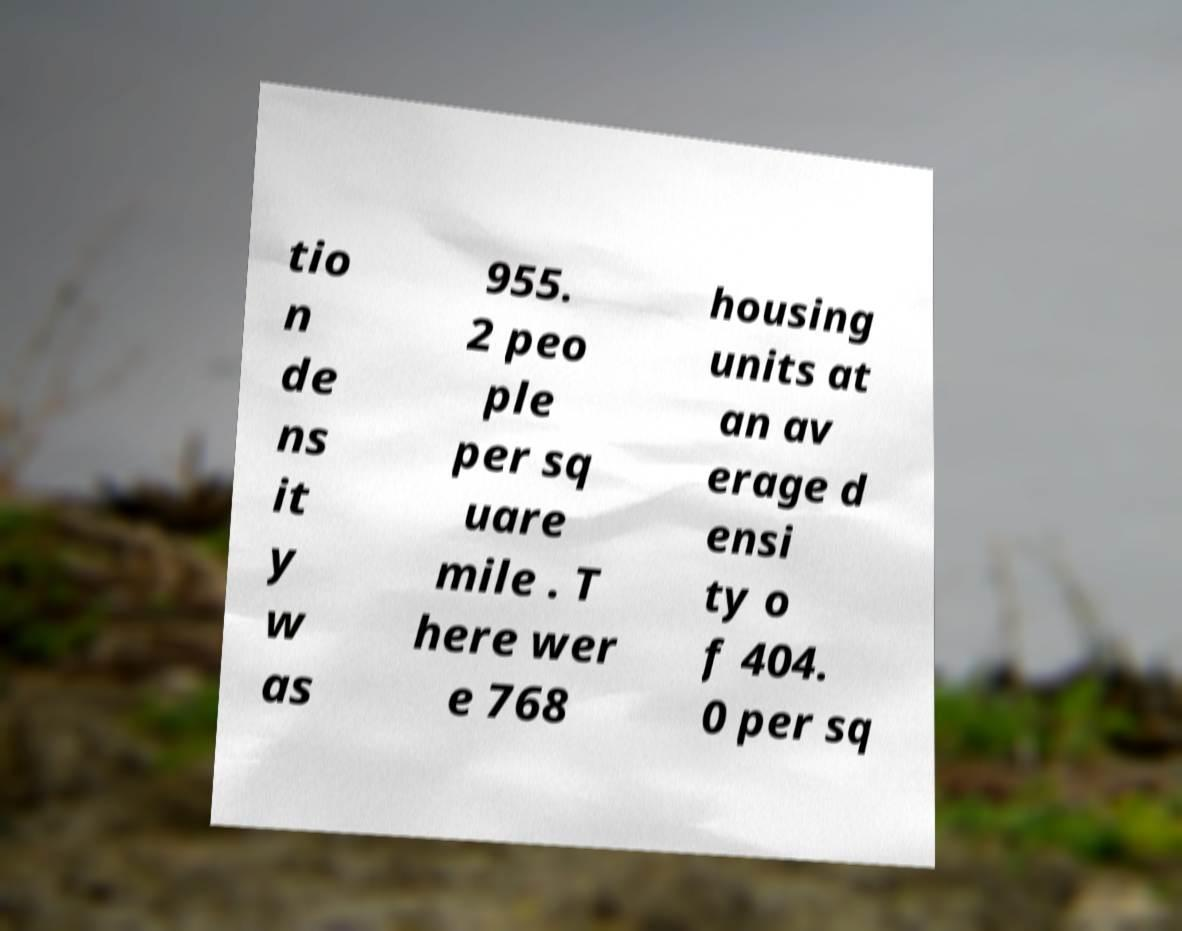Can you read and provide the text displayed in the image?This photo seems to have some interesting text. Can you extract and type it out for me? tio n de ns it y w as 955. 2 peo ple per sq uare mile . T here wer e 768 housing units at an av erage d ensi ty o f 404. 0 per sq 